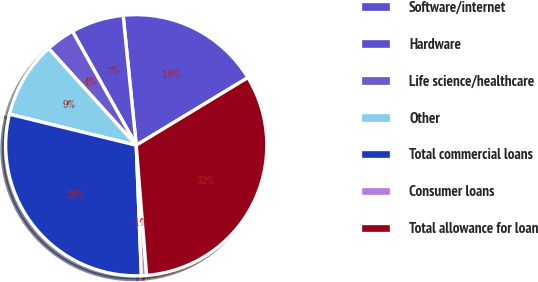<chart> <loc_0><loc_0><loc_500><loc_500><pie_chart><fcel>Software/internet<fcel>Hardware<fcel>Life science/healthcare<fcel>Other<fcel>Total commercial loans<fcel>Consumer loans<fcel>Total allowance for loan<nl><fcel>17.93%<fcel>6.53%<fcel>3.58%<fcel>9.47%<fcel>29.45%<fcel>0.64%<fcel>32.4%<nl></chart> 